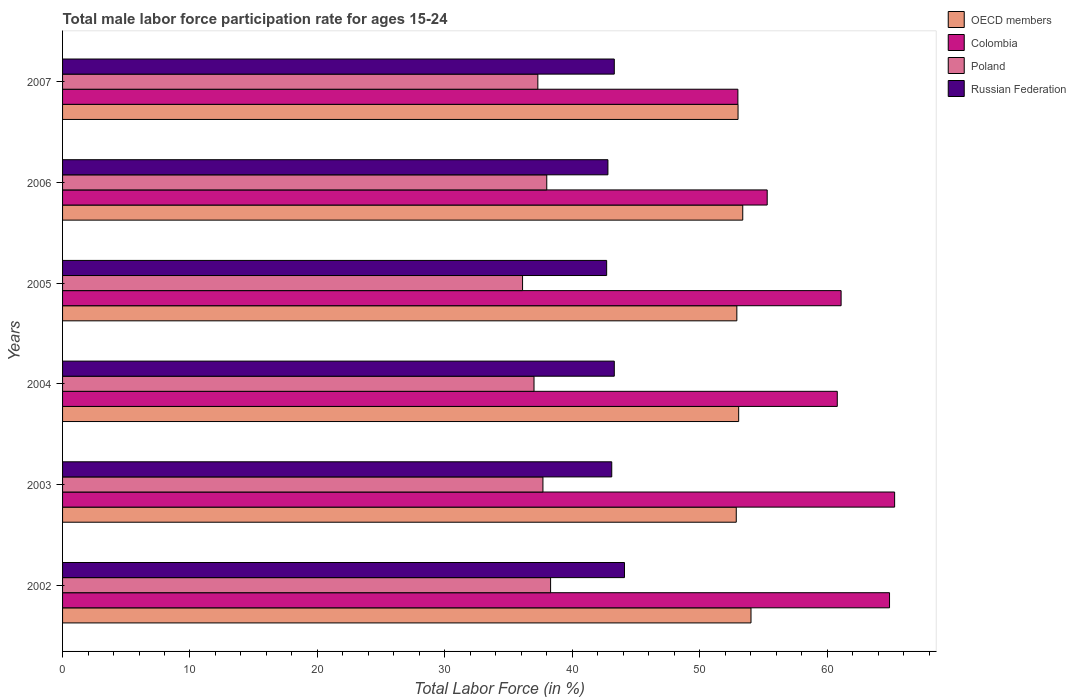Are the number of bars per tick equal to the number of legend labels?
Offer a very short reply. Yes. How many bars are there on the 4th tick from the bottom?
Give a very brief answer. 4. What is the label of the 5th group of bars from the top?
Offer a very short reply. 2003. In how many cases, is the number of bars for a given year not equal to the number of legend labels?
Your answer should be very brief. 0. What is the male labor force participation rate in Colombia in 2003?
Ensure brevity in your answer.  65.3. Across all years, what is the maximum male labor force participation rate in Poland?
Offer a terse response. 38.3. In which year was the male labor force participation rate in OECD members minimum?
Your answer should be compact. 2003. What is the total male labor force participation rate in Poland in the graph?
Keep it short and to the point. 224.4. What is the difference between the male labor force participation rate in OECD members in 2002 and that in 2007?
Ensure brevity in your answer.  1.02. What is the difference between the male labor force participation rate in Poland in 2005 and the male labor force participation rate in OECD members in 2007?
Make the answer very short. -16.91. What is the average male labor force participation rate in Poland per year?
Your response must be concise. 37.4. In the year 2002, what is the difference between the male labor force participation rate in OECD members and male labor force participation rate in Colombia?
Offer a very short reply. -10.87. In how many years, is the male labor force participation rate in Colombia greater than 52 %?
Your response must be concise. 6. What is the ratio of the male labor force participation rate in Colombia in 2006 to that in 2007?
Offer a very short reply. 1.04. Is the difference between the male labor force participation rate in OECD members in 2005 and 2007 greater than the difference between the male labor force participation rate in Colombia in 2005 and 2007?
Offer a terse response. No. What is the difference between the highest and the second highest male labor force participation rate in Poland?
Offer a terse response. 0.3. What is the difference between the highest and the lowest male labor force participation rate in OECD members?
Ensure brevity in your answer.  1.16. In how many years, is the male labor force participation rate in Poland greater than the average male labor force participation rate in Poland taken over all years?
Your answer should be compact. 3. Is the sum of the male labor force participation rate in OECD members in 2003 and 2005 greater than the maximum male labor force participation rate in Russian Federation across all years?
Offer a terse response. Yes. Is it the case that in every year, the sum of the male labor force participation rate in Poland and male labor force participation rate in Russian Federation is greater than the sum of male labor force participation rate in OECD members and male labor force participation rate in Colombia?
Your answer should be very brief. No. What does the 3rd bar from the top in 2002 represents?
Give a very brief answer. Colombia. What does the 4th bar from the bottom in 2003 represents?
Your answer should be compact. Russian Federation. How many bars are there?
Your answer should be compact. 24. Are all the bars in the graph horizontal?
Your answer should be compact. Yes. How many years are there in the graph?
Offer a terse response. 6. What is the difference between two consecutive major ticks on the X-axis?
Ensure brevity in your answer.  10. Are the values on the major ticks of X-axis written in scientific E-notation?
Your response must be concise. No. Does the graph contain any zero values?
Give a very brief answer. No. Does the graph contain grids?
Offer a very short reply. No. How many legend labels are there?
Provide a succinct answer. 4. How are the legend labels stacked?
Offer a terse response. Vertical. What is the title of the graph?
Make the answer very short. Total male labor force participation rate for ages 15-24. Does "Arab World" appear as one of the legend labels in the graph?
Give a very brief answer. No. What is the label or title of the Y-axis?
Provide a short and direct response. Years. What is the Total Labor Force (in %) in OECD members in 2002?
Give a very brief answer. 54.03. What is the Total Labor Force (in %) in Colombia in 2002?
Offer a very short reply. 64.9. What is the Total Labor Force (in %) in Poland in 2002?
Keep it short and to the point. 38.3. What is the Total Labor Force (in %) in Russian Federation in 2002?
Your answer should be compact. 44.1. What is the Total Labor Force (in %) in OECD members in 2003?
Give a very brief answer. 52.87. What is the Total Labor Force (in %) of Colombia in 2003?
Offer a terse response. 65.3. What is the Total Labor Force (in %) in Poland in 2003?
Offer a very short reply. 37.7. What is the Total Labor Force (in %) in Russian Federation in 2003?
Offer a very short reply. 43.1. What is the Total Labor Force (in %) in OECD members in 2004?
Ensure brevity in your answer.  53.06. What is the Total Labor Force (in %) of Colombia in 2004?
Give a very brief answer. 60.8. What is the Total Labor Force (in %) of Poland in 2004?
Offer a very short reply. 37. What is the Total Labor Force (in %) of Russian Federation in 2004?
Your response must be concise. 43.3. What is the Total Labor Force (in %) of OECD members in 2005?
Your answer should be very brief. 52.92. What is the Total Labor Force (in %) of Colombia in 2005?
Your answer should be compact. 61.1. What is the Total Labor Force (in %) of Poland in 2005?
Your answer should be compact. 36.1. What is the Total Labor Force (in %) of Russian Federation in 2005?
Your answer should be very brief. 42.7. What is the Total Labor Force (in %) of OECD members in 2006?
Offer a terse response. 53.38. What is the Total Labor Force (in %) in Colombia in 2006?
Your response must be concise. 55.3. What is the Total Labor Force (in %) in Russian Federation in 2006?
Keep it short and to the point. 42.8. What is the Total Labor Force (in %) of OECD members in 2007?
Offer a very short reply. 53.01. What is the Total Labor Force (in %) of Poland in 2007?
Your answer should be compact. 37.3. What is the Total Labor Force (in %) in Russian Federation in 2007?
Provide a short and direct response. 43.3. Across all years, what is the maximum Total Labor Force (in %) of OECD members?
Ensure brevity in your answer.  54.03. Across all years, what is the maximum Total Labor Force (in %) of Colombia?
Offer a very short reply. 65.3. Across all years, what is the maximum Total Labor Force (in %) of Poland?
Make the answer very short. 38.3. Across all years, what is the maximum Total Labor Force (in %) of Russian Federation?
Offer a terse response. 44.1. Across all years, what is the minimum Total Labor Force (in %) of OECD members?
Provide a short and direct response. 52.87. Across all years, what is the minimum Total Labor Force (in %) in Colombia?
Your answer should be very brief. 53. Across all years, what is the minimum Total Labor Force (in %) in Poland?
Offer a terse response. 36.1. Across all years, what is the minimum Total Labor Force (in %) in Russian Federation?
Offer a very short reply. 42.7. What is the total Total Labor Force (in %) in OECD members in the graph?
Ensure brevity in your answer.  319.27. What is the total Total Labor Force (in %) of Colombia in the graph?
Offer a terse response. 360.4. What is the total Total Labor Force (in %) of Poland in the graph?
Offer a terse response. 224.4. What is the total Total Labor Force (in %) of Russian Federation in the graph?
Keep it short and to the point. 259.3. What is the difference between the Total Labor Force (in %) of OECD members in 2002 and that in 2003?
Provide a succinct answer. 1.16. What is the difference between the Total Labor Force (in %) of OECD members in 2002 and that in 2004?
Give a very brief answer. 0.97. What is the difference between the Total Labor Force (in %) of Colombia in 2002 and that in 2004?
Ensure brevity in your answer.  4.1. What is the difference between the Total Labor Force (in %) in Poland in 2002 and that in 2004?
Your answer should be compact. 1.3. What is the difference between the Total Labor Force (in %) in OECD members in 2002 and that in 2005?
Keep it short and to the point. 1.11. What is the difference between the Total Labor Force (in %) in Colombia in 2002 and that in 2005?
Keep it short and to the point. 3.8. What is the difference between the Total Labor Force (in %) in Poland in 2002 and that in 2005?
Your answer should be very brief. 2.2. What is the difference between the Total Labor Force (in %) of OECD members in 2002 and that in 2006?
Provide a short and direct response. 0.65. What is the difference between the Total Labor Force (in %) in Russian Federation in 2002 and that in 2006?
Give a very brief answer. 1.3. What is the difference between the Total Labor Force (in %) in OECD members in 2002 and that in 2007?
Make the answer very short. 1.02. What is the difference between the Total Labor Force (in %) in Colombia in 2002 and that in 2007?
Keep it short and to the point. 11.9. What is the difference between the Total Labor Force (in %) of Poland in 2002 and that in 2007?
Offer a terse response. 1. What is the difference between the Total Labor Force (in %) in Russian Federation in 2002 and that in 2007?
Make the answer very short. 0.8. What is the difference between the Total Labor Force (in %) in OECD members in 2003 and that in 2004?
Your answer should be very brief. -0.19. What is the difference between the Total Labor Force (in %) in Colombia in 2003 and that in 2004?
Offer a terse response. 4.5. What is the difference between the Total Labor Force (in %) of Russian Federation in 2003 and that in 2004?
Your answer should be very brief. -0.2. What is the difference between the Total Labor Force (in %) of OECD members in 2003 and that in 2005?
Provide a succinct answer. -0.05. What is the difference between the Total Labor Force (in %) of Poland in 2003 and that in 2005?
Keep it short and to the point. 1.6. What is the difference between the Total Labor Force (in %) of OECD members in 2003 and that in 2006?
Give a very brief answer. -0.51. What is the difference between the Total Labor Force (in %) in OECD members in 2003 and that in 2007?
Offer a terse response. -0.14. What is the difference between the Total Labor Force (in %) in Poland in 2003 and that in 2007?
Give a very brief answer. 0.4. What is the difference between the Total Labor Force (in %) in OECD members in 2004 and that in 2005?
Your answer should be very brief. 0.14. What is the difference between the Total Labor Force (in %) in OECD members in 2004 and that in 2006?
Your answer should be compact. -0.32. What is the difference between the Total Labor Force (in %) of Poland in 2004 and that in 2006?
Your answer should be very brief. -1. What is the difference between the Total Labor Force (in %) of OECD members in 2004 and that in 2007?
Offer a terse response. 0.05. What is the difference between the Total Labor Force (in %) in Russian Federation in 2004 and that in 2007?
Make the answer very short. 0. What is the difference between the Total Labor Force (in %) of OECD members in 2005 and that in 2006?
Give a very brief answer. -0.46. What is the difference between the Total Labor Force (in %) in Colombia in 2005 and that in 2006?
Your response must be concise. 5.8. What is the difference between the Total Labor Force (in %) in Russian Federation in 2005 and that in 2006?
Keep it short and to the point. -0.1. What is the difference between the Total Labor Force (in %) of OECD members in 2005 and that in 2007?
Ensure brevity in your answer.  -0.09. What is the difference between the Total Labor Force (in %) in Poland in 2005 and that in 2007?
Give a very brief answer. -1.2. What is the difference between the Total Labor Force (in %) of Russian Federation in 2005 and that in 2007?
Offer a very short reply. -0.6. What is the difference between the Total Labor Force (in %) in OECD members in 2006 and that in 2007?
Provide a short and direct response. 0.37. What is the difference between the Total Labor Force (in %) in Poland in 2006 and that in 2007?
Offer a very short reply. 0.7. What is the difference between the Total Labor Force (in %) in Russian Federation in 2006 and that in 2007?
Offer a terse response. -0.5. What is the difference between the Total Labor Force (in %) in OECD members in 2002 and the Total Labor Force (in %) in Colombia in 2003?
Offer a very short reply. -11.27. What is the difference between the Total Labor Force (in %) in OECD members in 2002 and the Total Labor Force (in %) in Poland in 2003?
Offer a very short reply. 16.33. What is the difference between the Total Labor Force (in %) of OECD members in 2002 and the Total Labor Force (in %) of Russian Federation in 2003?
Make the answer very short. 10.93. What is the difference between the Total Labor Force (in %) in Colombia in 2002 and the Total Labor Force (in %) in Poland in 2003?
Offer a terse response. 27.2. What is the difference between the Total Labor Force (in %) in Colombia in 2002 and the Total Labor Force (in %) in Russian Federation in 2003?
Your answer should be compact. 21.8. What is the difference between the Total Labor Force (in %) in Poland in 2002 and the Total Labor Force (in %) in Russian Federation in 2003?
Make the answer very short. -4.8. What is the difference between the Total Labor Force (in %) in OECD members in 2002 and the Total Labor Force (in %) in Colombia in 2004?
Provide a short and direct response. -6.77. What is the difference between the Total Labor Force (in %) in OECD members in 2002 and the Total Labor Force (in %) in Poland in 2004?
Your answer should be very brief. 17.03. What is the difference between the Total Labor Force (in %) in OECD members in 2002 and the Total Labor Force (in %) in Russian Federation in 2004?
Keep it short and to the point. 10.73. What is the difference between the Total Labor Force (in %) of Colombia in 2002 and the Total Labor Force (in %) of Poland in 2004?
Your response must be concise. 27.9. What is the difference between the Total Labor Force (in %) in Colombia in 2002 and the Total Labor Force (in %) in Russian Federation in 2004?
Keep it short and to the point. 21.6. What is the difference between the Total Labor Force (in %) in OECD members in 2002 and the Total Labor Force (in %) in Colombia in 2005?
Your answer should be very brief. -7.07. What is the difference between the Total Labor Force (in %) of OECD members in 2002 and the Total Labor Force (in %) of Poland in 2005?
Provide a short and direct response. 17.93. What is the difference between the Total Labor Force (in %) of OECD members in 2002 and the Total Labor Force (in %) of Russian Federation in 2005?
Provide a succinct answer. 11.33. What is the difference between the Total Labor Force (in %) in Colombia in 2002 and the Total Labor Force (in %) in Poland in 2005?
Offer a very short reply. 28.8. What is the difference between the Total Labor Force (in %) of Colombia in 2002 and the Total Labor Force (in %) of Russian Federation in 2005?
Your answer should be compact. 22.2. What is the difference between the Total Labor Force (in %) of Poland in 2002 and the Total Labor Force (in %) of Russian Federation in 2005?
Offer a very short reply. -4.4. What is the difference between the Total Labor Force (in %) in OECD members in 2002 and the Total Labor Force (in %) in Colombia in 2006?
Keep it short and to the point. -1.27. What is the difference between the Total Labor Force (in %) of OECD members in 2002 and the Total Labor Force (in %) of Poland in 2006?
Offer a terse response. 16.03. What is the difference between the Total Labor Force (in %) of OECD members in 2002 and the Total Labor Force (in %) of Russian Federation in 2006?
Give a very brief answer. 11.23. What is the difference between the Total Labor Force (in %) in Colombia in 2002 and the Total Labor Force (in %) in Poland in 2006?
Provide a short and direct response. 26.9. What is the difference between the Total Labor Force (in %) in Colombia in 2002 and the Total Labor Force (in %) in Russian Federation in 2006?
Provide a succinct answer. 22.1. What is the difference between the Total Labor Force (in %) in OECD members in 2002 and the Total Labor Force (in %) in Colombia in 2007?
Provide a short and direct response. 1.03. What is the difference between the Total Labor Force (in %) of OECD members in 2002 and the Total Labor Force (in %) of Poland in 2007?
Your answer should be very brief. 16.73. What is the difference between the Total Labor Force (in %) of OECD members in 2002 and the Total Labor Force (in %) of Russian Federation in 2007?
Your response must be concise. 10.73. What is the difference between the Total Labor Force (in %) of Colombia in 2002 and the Total Labor Force (in %) of Poland in 2007?
Your answer should be very brief. 27.6. What is the difference between the Total Labor Force (in %) of Colombia in 2002 and the Total Labor Force (in %) of Russian Federation in 2007?
Make the answer very short. 21.6. What is the difference between the Total Labor Force (in %) of OECD members in 2003 and the Total Labor Force (in %) of Colombia in 2004?
Your answer should be very brief. -7.93. What is the difference between the Total Labor Force (in %) in OECD members in 2003 and the Total Labor Force (in %) in Poland in 2004?
Provide a short and direct response. 15.87. What is the difference between the Total Labor Force (in %) of OECD members in 2003 and the Total Labor Force (in %) of Russian Federation in 2004?
Keep it short and to the point. 9.57. What is the difference between the Total Labor Force (in %) in Colombia in 2003 and the Total Labor Force (in %) in Poland in 2004?
Offer a terse response. 28.3. What is the difference between the Total Labor Force (in %) in Colombia in 2003 and the Total Labor Force (in %) in Russian Federation in 2004?
Offer a terse response. 22. What is the difference between the Total Labor Force (in %) of OECD members in 2003 and the Total Labor Force (in %) of Colombia in 2005?
Ensure brevity in your answer.  -8.23. What is the difference between the Total Labor Force (in %) of OECD members in 2003 and the Total Labor Force (in %) of Poland in 2005?
Keep it short and to the point. 16.77. What is the difference between the Total Labor Force (in %) in OECD members in 2003 and the Total Labor Force (in %) in Russian Federation in 2005?
Your answer should be very brief. 10.17. What is the difference between the Total Labor Force (in %) in Colombia in 2003 and the Total Labor Force (in %) in Poland in 2005?
Ensure brevity in your answer.  29.2. What is the difference between the Total Labor Force (in %) of Colombia in 2003 and the Total Labor Force (in %) of Russian Federation in 2005?
Provide a short and direct response. 22.6. What is the difference between the Total Labor Force (in %) in OECD members in 2003 and the Total Labor Force (in %) in Colombia in 2006?
Offer a terse response. -2.43. What is the difference between the Total Labor Force (in %) in OECD members in 2003 and the Total Labor Force (in %) in Poland in 2006?
Your answer should be very brief. 14.87. What is the difference between the Total Labor Force (in %) of OECD members in 2003 and the Total Labor Force (in %) of Russian Federation in 2006?
Your answer should be compact. 10.07. What is the difference between the Total Labor Force (in %) in Colombia in 2003 and the Total Labor Force (in %) in Poland in 2006?
Keep it short and to the point. 27.3. What is the difference between the Total Labor Force (in %) of Colombia in 2003 and the Total Labor Force (in %) of Russian Federation in 2006?
Make the answer very short. 22.5. What is the difference between the Total Labor Force (in %) in OECD members in 2003 and the Total Labor Force (in %) in Colombia in 2007?
Provide a succinct answer. -0.13. What is the difference between the Total Labor Force (in %) of OECD members in 2003 and the Total Labor Force (in %) of Poland in 2007?
Offer a terse response. 15.57. What is the difference between the Total Labor Force (in %) of OECD members in 2003 and the Total Labor Force (in %) of Russian Federation in 2007?
Make the answer very short. 9.57. What is the difference between the Total Labor Force (in %) of OECD members in 2004 and the Total Labor Force (in %) of Colombia in 2005?
Your answer should be very brief. -8.04. What is the difference between the Total Labor Force (in %) in OECD members in 2004 and the Total Labor Force (in %) in Poland in 2005?
Ensure brevity in your answer.  16.96. What is the difference between the Total Labor Force (in %) of OECD members in 2004 and the Total Labor Force (in %) of Russian Federation in 2005?
Your answer should be compact. 10.36. What is the difference between the Total Labor Force (in %) in Colombia in 2004 and the Total Labor Force (in %) in Poland in 2005?
Your answer should be very brief. 24.7. What is the difference between the Total Labor Force (in %) of Colombia in 2004 and the Total Labor Force (in %) of Russian Federation in 2005?
Offer a very short reply. 18.1. What is the difference between the Total Labor Force (in %) of OECD members in 2004 and the Total Labor Force (in %) of Colombia in 2006?
Provide a succinct answer. -2.24. What is the difference between the Total Labor Force (in %) in OECD members in 2004 and the Total Labor Force (in %) in Poland in 2006?
Provide a short and direct response. 15.06. What is the difference between the Total Labor Force (in %) in OECD members in 2004 and the Total Labor Force (in %) in Russian Federation in 2006?
Your response must be concise. 10.26. What is the difference between the Total Labor Force (in %) in Colombia in 2004 and the Total Labor Force (in %) in Poland in 2006?
Your answer should be compact. 22.8. What is the difference between the Total Labor Force (in %) of Colombia in 2004 and the Total Labor Force (in %) of Russian Federation in 2006?
Offer a terse response. 18. What is the difference between the Total Labor Force (in %) in OECD members in 2004 and the Total Labor Force (in %) in Colombia in 2007?
Provide a succinct answer. 0.06. What is the difference between the Total Labor Force (in %) in OECD members in 2004 and the Total Labor Force (in %) in Poland in 2007?
Your response must be concise. 15.76. What is the difference between the Total Labor Force (in %) in OECD members in 2004 and the Total Labor Force (in %) in Russian Federation in 2007?
Your answer should be compact. 9.76. What is the difference between the Total Labor Force (in %) in Colombia in 2004 and the Total Labor Force (in %) in Russian Federation in 2007?
Your answer should be compact. 17.5. What is the difference between the Total Labor Force (in %) in OECD members in 2005 and the Total Labor Force (in %) in Colombia in 2006?
Your response must be concise. -2.38. What is the difference between the Total Labor Force (in %) in OECD members in 2005 and the Total Labor Force (in %) in Poland in 2006?
Provide a succinct answer. 14.92. What is the difference between the Total Labor Force (in %) in OECD members in 2005 and the Total Labor Force (in %) in Russian Federation in 2006?
Your answer should be compact. 10.12. What is the difference between the Total Labor Force (in %) of Colombia in 2005 and the Total Labor Force (in %) of Poland in 2006?
Offer a very short reply. 23.1. What is the difference between the Total Labor Force (in %) in Colombia in 2005 and the Total Labor Force (in %) in Russian Federation in 2006?
Ensure brevity in your answer.  18.3. What is the difference between the Total Labor Force (in %) in OECD members in 2005 and the Total Labor Force (in %) in Colombia in 2007?
Your response must be concise. -0.08. What is the difference between the Total Labor Force (in %) of OECD members in 2005 and the Total Labor Force (in %) of Poland in 2007?
Your answer should be compact. 15.62. What is the difference between the Total Labor Force (in %) of OECD members in 2005 and the Total Labor Force (in %) of Russian Federation in 2007?
Ensure brevity in your answer.  9.62. What is the difference between the Total Labor Force (in %) in Colombia in 2005 and the Total Labor Force (in %) in Poland in 2007?
Your answer should be very brief. 23.8. What is the difference between the Total Labor Force (in %) in Colombia in 2005 and the Total Labor Force (in %) in Russian Federation in 2007?
Provide a succinct answer. 17.8. What is the difference between the Total Labor Force (in %) in OECD members in 2006 and the Total Labor Force (in %) in Colombia in 2007?
Provide a short and direct response. 0.38. What is the difference between the Total Labor Force (in %) in OECD members in 2006 and the Total Labor Force (in %) in Poland in 2007?
Ensure brevity in your answer.  16.08. What is the difference between the Total Labor Force (in %) of OECD members in 2006 and the Total Labor Force (in %) of Russian Federation in 2007?
Your answer should be very brief. 10.08. What is the difference between the Total Labor Force (in %) in Poland in 2006 and the Total Labor Force (in %) in Russian Federation in 2007?
Your answer should be compact. -5.3. What is the average Total Labor Force (in %) in OECD members per year?
Offer a very short reply. 53.21. What is the average Total Labor Force (in %) in Colombia per year?
Your answer should be very brief. 60.07. What is the average Total Labor Force (in %) of Poland per year?
Your answer should be compact. 37.4. What is the average Total Labor Force (in %) in Russian Federation per year?
Offer a terse response. 43.22. In the year 2002, what is the difference between the Total Labor Force (in %) in OECD members and Total Labor Force (in %) in Colombia?
Your response must be concise. -10.87. In the year 2002, what is the difference between the Total Labor Force (in %) of OECD members and Total Labor Force (in %) of Poland?
Your answer should be very brief. 15.73. In the year 2002, what is the difference between the Total Labor Force (in %) in OECD members and Total Labor Force (in %) in Russian Federation?
Provide a short and direct response. 9.93. In the year 2002, what is the difference between the Total Labor Force (in %) in Colombia and Total Labor Force (in %) in Poland?
Make the answer very short. 26.6. In the year 2002, what is the difference between the Total Labor Force (in %) of Colombia and Total Labor Force (in %) of Russian Federation?
Give a very brief answer. 20.8. In the year 2002, what is the difference between the Total Labor Force (in %) of Poland and Total Labor Force (in %) of Russian Federation?
Your answer should be very brief. -5.8. In the year 2003, what is the difference between the Total Labor Force (in %) in OECD members and Total Labor Force (in %) in Colombia?
Provide a succinct answer. -12.43. In the year 2003, what is the difference between the Total Labor Force (in %) of OECD members and Total Labor Force (in %) of Poland?
Your answer should be compact. 15.17. In the year 2003, what is the difference between the Total Labor Force (in %) of OECD members and Total Labor Force (in %) of Russian Federation?
Provide a succinct answer. 9.77. In the year 2003, what is the difference between the Total Labor Force (in %) of Colombia and Total Labor Force (in %) of Poland?
Provide a succinct answer. 27.6. In the year 2003, what is the difference between the Total Labor Force (in %) of Poland and Total Labor Force (in %) of Russian Federation?
Offer a terse response. -5.4. In the year 2004, what is the difference between the Total Labor Force (in %) in OECD members and Total Labor Force (in %) in Colombia?
Offer a terse response. -7.74. In the year 2004, what is the difference between the Total Labor Force (in %) in OECD members and Total Labor Force (in %) in Poland?
Offer a very short reply. 16.06. In the year 2004, what is the difference between the Total Labor Force (in %) of OECD members and Total Labor Force (in %) of Russian Federation?
Your response must be concise. 9.76. In the year 2004, what is the difference between the Total Labor Force (in %) in Colombia and Total Labor Force (in %) in Poland?
Your answer should be compact. 23.8. In the year 2005, what is the difference between the Total Labor Force (in %) in OECD members and Total Labor Force (in %) in Colombia?
Offer a very short reply. -8.18. In the year 2005, what is the difference between the Total Labor Force (in %) in OECD members and Total Labor Force (in %) in Poland?
Your answer should be very brief. 16.82. In the year 2005, what is the difference between the Total Labor Force (in %) of OECD members and Total Labor Force (in %) of Russian Federation?
Keep it short and to the point. 10.22. In the year 2005, what is the difference between the Total Labor Force (in %) of Colombia and Total Labor Force (in %) of Poland?
Your answer should be compact. 25. In the year 2005, what is the difference between the Total Labor Force (in %) in Poland and Total Labor Force (in %) in Russian Federation?
Ensure brevity in your answer.  -6.6. In the year 2006, what is the difference between the Total Labor Force (in %) in OECD members and Total Labor Force (in %) in Colombia?
Provide a succinct answer. -1.92. In the year 2006, what is the difference between the Total Labor Force (in %) in OECD members and Total Labor Force (in %) in Poland?
Your answer should be compact. 15.38. In the year 2006, what is the difference between the Total Labor Force (in %) of OECD members and Total Labor Force (in %) of Russian Federation?
Provide a short and direct response. 10.58. In the year 2006, what is the difference between the Total Labor Force (in %) of Colombia and Total Labor Force (in %) of Poland?
Give a very brief answer. 17.3. In the year 2007, what is the difference between the Total Labor Force (in %) in OECD members and Total Labor Force (in %) in Colombia?
Give a very brief answer. 0.01. In the year 2007, what is the difference between the Total Labor Force (in %) in OECD members and Total Labor Force (in %) in Poland?
Provide a short and direct response. 15.71. In the year 2007, what is the difference between the Total Labor Force (in %) of OECD members and Total Labor Force (in %) of Russian Federation?
Ensure brevity in your answer.  9.71. In the year 2007, what is the difference between the Total Labor Force (in %) of Colombia and Total Labor Force (in %) of Poland?
Your answer should be very brief. 15.7. In the year 2007, what is the difference between the Total Labor Force (in %) in Colombia and Total Labor Force (in %) in Russian Federation?
Ensure brevity in your answer.  9.7. What is the ratio of the Total Labor Force (in %) of OECD members in 2002 to that in 2003?
Make the answer very short. 1.02. What is the ratio of the Total Labor Force (in %) in Colombia in 2002 to that in 2003?
Offer a terse response. 0.99. What is the ratio of the Total Labor Force (in %) of Poland in 2002 to that in 2003?
Provide a succinct answer. 1.02. What is the ratio of the Total Labor Force (in %) of Russian Federation in 2002 to that in 2003?
Provide a short and direct response. 1.02. What is the ratio of the Total Labor Force (in %) in OECD members in 2002 to that in 2004?
Provide a succinct answer. 1.02. What is the ratio of the Total Labor Force (in %) in Colombia in 2002 to that in 2004?
Offer a very short reply. 1.07. What is the ratio of the Total Labor Force (in %) of Poland in 2002 to that in 2004?
Your answer should be compact. 1.04. What is the ratio of the Total Labor Force (in %) of Russian Federation in 2002 to that in 2004?
Keep it short and to the point. 1.02. What is the ratio of the Total Labor Force (in %) in OECD members in 2002 to that in 2005?
Your response must be concise. 1.02. What is the ratio of the Total Labor Force (in %) in Colombia in 2002 to that in 2005?
Provide a succinct answer. 1.06. What is the ratio of the Total Labor Force (in %) of Poland in 2002 to that in 2005?
Make the answer very short. 1.06. What is the ratio of the Total Labor Force (in %) in Russian Federation in 2002 to that in 2005?
Ensure brevity in your answer.  1.03. What is the ratio of the Total Labor Force (in %) in OECD members in 2002 to that in 2006?
Offer a terse response. 1.01. What is the ratio of the Total Labor Force (in %) of Colombia in 2002 to that in 2006?
Give a very brief answer. 1.17. What is the ratio of the Total Labor Force (in %) of Poland in 2002 to that in 2006?
Offer a very short reply. 1.01. What is the ratio of the Total Labor Force (in %) of Russian Federation in 2002 to that in 2006?
Keep it short and to the point. 1.03. What is the ratio of the Total Labor Force (in %) in OECD members in 2002 to that in 2007?
Offer a very short reply. 1.02. What is the ratio of the Total Labor Force (in %) of Colombia in 2002 to that in 2007?
Your answer should be compact. 1.22. What is the ratio of the Total Labor Force (in %) of Poland in 2002 to that in 2007?
Ensure brevity in your answer.  1.03. What is the ratio of the Total Labor Force (in %) in Russian Federation in 2002 to that in 2007?
Your answer should be very brief. 1.02. What is the ratio of the Total Labor Force (in %) in Colombia in 2003 to that in 2004?
Make the answer very short. 1.07. What is the ratio of the Total Labor Force (in %) in Poland in 2003 to that in 2004?
Offer a very short reply. 1.02. What is the ratio of the Total Labor Force (in %) of Colombia in 2003 to that in 2005?
Keep it short and to the point. 1.07. What is the ratio of the Total Labor Force (in %) of Poland in 2003 to that in 2005?
Make the answer very short. 1.04. What is the ratio of the Total Labor Force (in %) of Russian Federation in 2003 to that in 2005?
Offer a very short reply. 1.01. What is the ratio of the Total Labor Force (in %) of OECD members in 2003 to that in 2006?
Make the answer very short. 0.99. What is the ratio of the Total Labor Force (in %) of Colombia in 2003 to that in 2006?
Your answer should be compact. 1.18. What is the ratio of the Total Labor Force (in %) of Colombia in 2003 to that in 2007?
Ensure brevity in your answer.  1.23. What is the ratio of the Total Labor Force (in %) of Poland in 2003 to that in 2007?
Provide a succinct answer. 1.01. What is the ratio of the Total Labor Force (in %) in Russian Federation in 2003 to that in 2007?
Provide a succinct answer. 1. What is the ratio of the Total Labor Force (in %) of Colombia in 2004 to that in 2005?
Give a very brief answer. 1. What is the ratio of the Total Labor Force (in %) of Poland in 2004 to that in 2005?
Keep it short and to the point. 1.02. What is the ratio of the Total Labor Force (in %) in Russian Federation in 2004 to that in 2005?
Ensure brevity in your answer.  1.01. What is the ratio of the Total Labor Force (in %) in Colombia in 2004 to that in 2006?
Your response must be concise. 1.1. What is the ratio of the Total Labor Force (in %) of Poland in 2004 to that in 2006?
Provide a short and direct response. 0.97. What is the ratio of the Total Labor Force (in %) of Russian Federation in 2004 to that in 2006?
Make the answer very short. 1.01. What is the ratio of the Total Labor Force (in %) of OECD members in 2004 to that in 2007?
Offer a terse response. 1. What is the ratio of the Total Labor Force (in %) of Colombia in 2004 to that in 2007?
Make the answer very short. 1.15. What is the ratio of the Total Labor Force (in %) of OECD members in 2005 to that in 2006?
Give a very brief answer. 0.99. What is the ratio of the Total Labor Force (in %) in Colombia in 2005 to that in 2006?
Offer a very short reply. 1.1. What is the ratio of the Total Labor Force (in %) in Russian Federation in 2005 to that in 2006?
Your response must be concise. 1. What is the ratio of the Total Labor Force (in %) in Colombia in 2005 to that in 2007?
Provide a succinct answer. 1.15. What is the ratio of the Total Labor Force (in %) in Poland in 2005 to that in 2007?
Your response must be concise. 0.97. What is the ratio of the Total Labor Force (in %) in Russian Federation in 2005 to that in 2007?
Give a very brief answer. 0.99. What is the ratio of the Total Labor Force (in %) in OECD members in 2006 to that in 2007?
Give a very brief answer. 1.01. What is the ratio of the Total Labor Force (in %) in Colombia in 2006 to that in 2007?
Give a very brief answer. 1.04. What is the ratio of the Total Labor Force (in %) in Poland in 2006 to that in 2007?
Keep it short and to the point. 1.02. What is the difference between the highest and the second highest Total Labor Force (in %) of OECD members?
Make the answer very short. 0.65. What is the difference between the highest and the second highest Total Labor Force (in %) of Colombia?
Offer a very short reply. 0.4. What is the difference between the highest and the second highest Total Labor Force (in %) in Poland?
Make the answer very short. 0.3. What is the difference between the highest and the second highest Total Labor Force (in %) in Russian Federation?
Offer a terse response. 0.8. What is the difference between the highest and the lowest Total Labor Force (in %) of OECD members?
Your response must be concise. 1.16. What is the difference between the highest and the lowest Total Labor Force (in %) in Russian Federation?
Give a very brief answer. 1.4. 